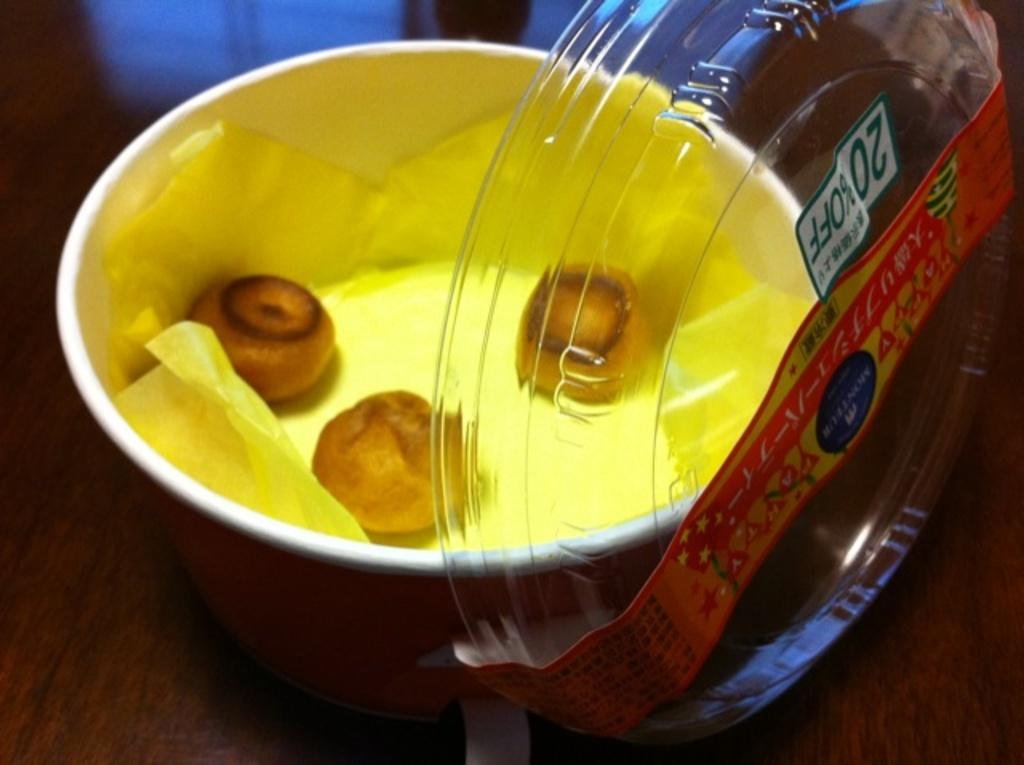What type of items can be seen in the image? There are eatables in the image. How are the eatables contained or organized? The eatables are placed in a paper box. What is the surface on which the paper box is placed? The paper box is placed on a brown surface. What type of punishment is being handed out in the image? There is no punishment being handed out in the image; it features eatables in a paper box on a brown surface. 